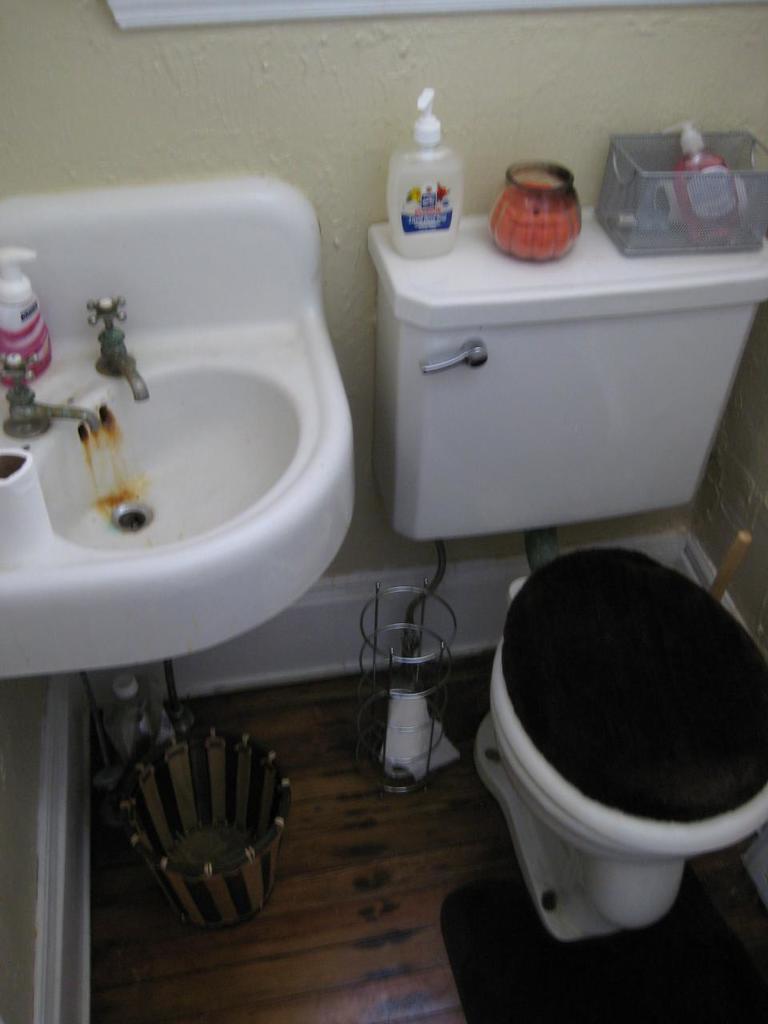Could you give a brief overview of what you see in this image? In this image, I can see a wash basin and a flush tank, which are attached to a wall. It looks like a toilet seat with a toilet lid. I think this is a dustbin, which is under the washbasin. I can see the bottles and few objects on a wash basin and a flush tank. At the bottom of the image, I can see the floor with a mat on it. 